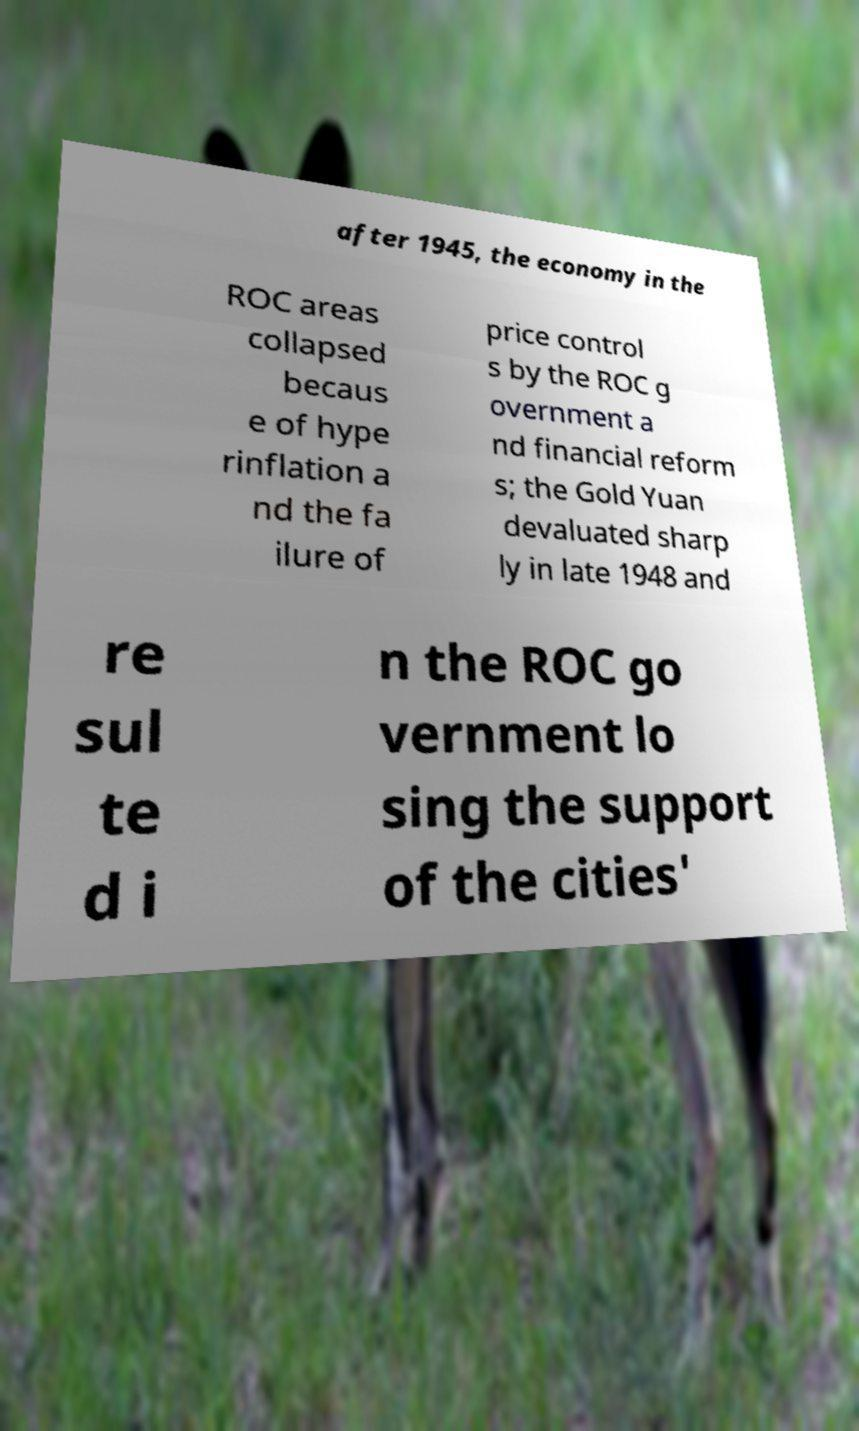I need the written content from this picture converted into text. Can you do that? after 1945, the economy in the ROC areas collapsed becaus e of hype rinflation a nd the fa ilure of price control s by the ROC g overnment a nd financial reform s; the Gold Yuan devaluated sharp ly in late 1948 and re sul te d i n the ROC go vernment lo sing the support of the cities' 